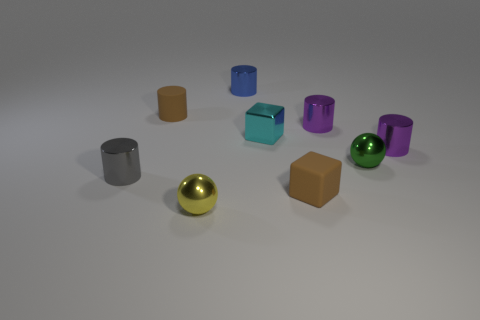Subtract all brown cylinders. How many cylinders are left? 4 Subtract all cylinders. How many objects are left? 4 Subtract 5 cylinders. How many cylinders are left? 0 Subtract all blue cubes. How many green spheres are left? 1 Subtract all big gray things. Subtract all tiny matte cubes. How many objects are left? 8 Add 3 green balls. How many green balls are left? 4 Add 7 brown things. How many brown things exist? 9 Subtract all brown cubes. How many cubes are left? 1 Subtract 0 yellow cubes. How many objects are left? 9 Subtract all yellow cylinders. Subtract all yellow blocks. How many cylinders are left? 5 